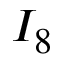<formula> <loc_0><loc_0><loc_500><loc_500>I _ { 8 }</formula> 